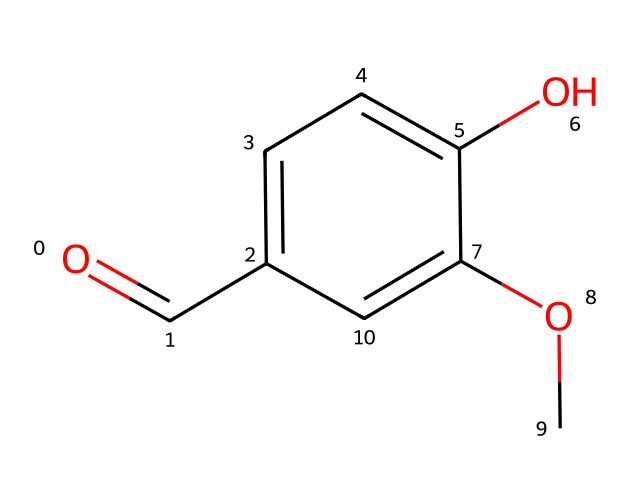What is the molecular formula of vanillin? To determine the molecular formula from the SMILES representation O=Cc1ccc(O)c(OC)c1, count each type of atom. The structure includes 8 carbons (C), 8 hydrogens (H), and 3 oxygens (O). Thus, the molecular formula is C8H8O3.
Answer: C8H8O3 How many rings are present in vanillin's structure? The provided SMILES shows a benzene ring structure (c1ccc), which indicates the presence of one aromatic ring in the molecule.
Answer: 1 What functional groups are present in vanillin? Analyzing the SMILES structure reveals a hydroxyl group (-OH) and a methoxy group (-OCH3) attached to the aromatic ring, contributing to the characteristic functional groups of vanillin.
Answer: hydroxyl and methoxy What is the role of the hydroxyl group in vanillin? The hydroxyl group (-OH) is known to enhance the compound's solubility and contributes to vanillin's flavor profile by providing a sweet and creamy note, thus important for its classification as a flavoring agent.
Answer: enhances flavor What type of aroma does vanillin primarily contribute to in food? Vanillin is primarily known for its sweet, vanilla-like aroma, which is why it is commonly used in various food products, especially desserts.
Answer: sweet vanilla How does the methoxy group influence the flavor profile of vanillin? The methoxy group (–OCH3) in vanillin stabilizes the aromatic system and enhances its sweetness perception, which is crucial in flavoring applications, making it a valuable compound in food science.
Answer: enhances sweetness 